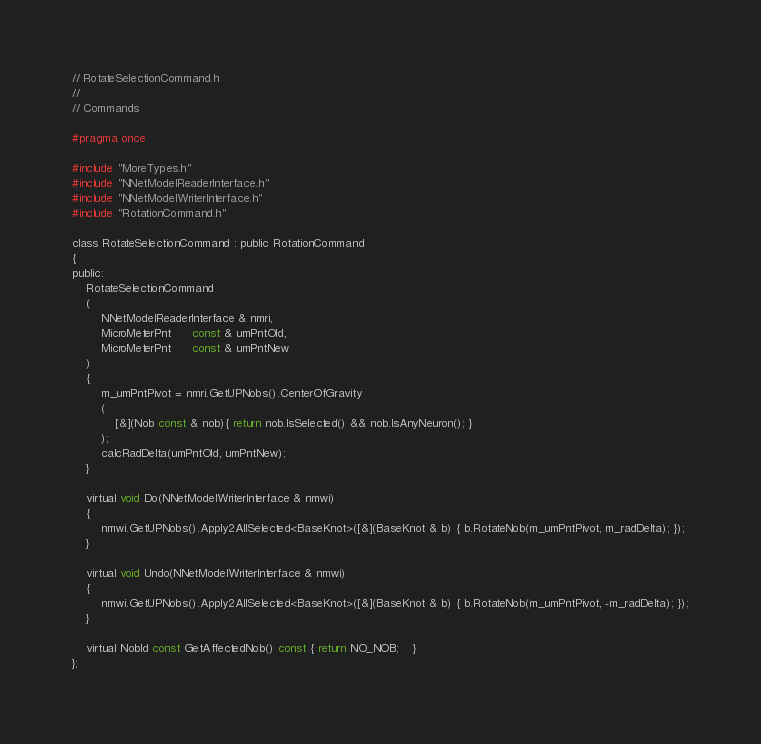<code> <loc_0><loc_0><loc_500><loc_500><_C_>// RotateSelectionCommand.h
//
// Commands

#pragma once

#include "MoreTypes.h"
#include "NNetModelReaderInterface.h"
#include "NNetModelWriterInterface.h"
#include "RotationCommand.h"

class RotateSelectionCommand : public RotationCommand
{
public:
	RotateSelectionCommand
	(
		NNetModelReaderInterface & nmri,
		MicroMeterPnt      const & umPntOld, 
		MicroMeterPnt      const & umPntNew
	)
	{
		m_umPntPivot = nmri.GetUPNobs().CenterOfGravity
		(
			[&](Nob const & nob){ return nob.IsSelected() && nob.IsAnyNeuron(); }
		);
		calcRadDelta(umPntOld, umPntNew);
	}

	virtual void Do(NNetModelWriterInterface & nmwi) 
	{ 
		nmwi.GetUPNobs().Apply2AllSelected<BaseKnot>([&](BaseKnot & b) { b.RotateNob(m_umPntPivot, m_radDelta); });
	}

	virtual void Undo(NNetModelWriterInterface & nmwi) 
	{ 
		nmwi.GetUPNobs().Apply2AllSelected<BaseKnot>([&](BaseKnot & b) { b.RotateNob(m_umPntPivot, -m_radDelta); });
	}

	virtual NobId const GetAffectedNob() const { return NO_NOB;	}
};
</code> 